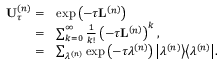<formula> <loc_0><loc_0><loc_500><loc_500>\begin{array} { r l } { U _ { \tau } ^ { \left ( n \right ) } = } & { \exp \left ( - \tau L ^ { \left ( n \right ) } \right ) } \\ { = } & { \sum _ { k = 0 } ^ { \infty } \frac { 1 } { k ! } \left ( - \tau L ^ { \left ( n \right ) } \right ) ^ { k } , } \\ { = } & { \sum _ { \lambda ^ { \left ( n \right ) } } \exp \left ( - \tau \lambda ^ { \left ( n \right ) } \right ) \left | \lambda ^ { \left ( n \right ) } \right \rangle \left \langle \lambda ^ { \left ( n \right ) } \right | . } \end{array}</formula> 